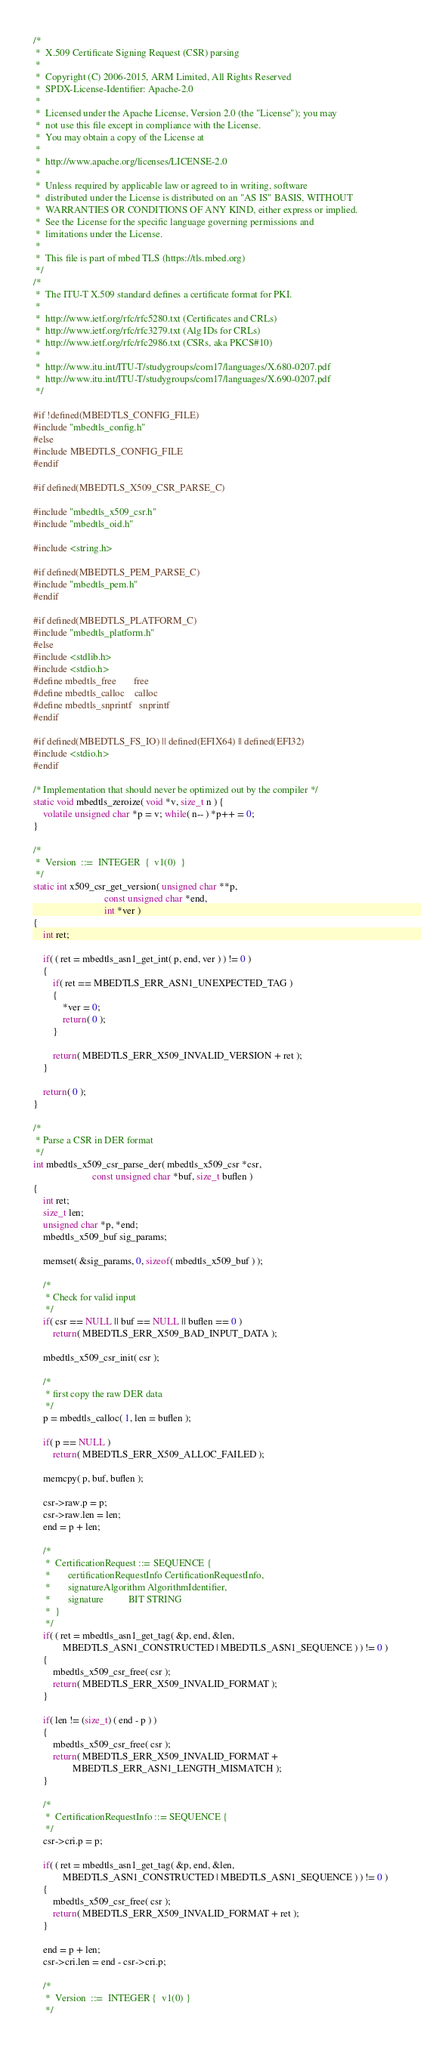<code> <loc_0><loc_0><loc_500><loc_500><_C_>/*
 *  X.509 Certificate Signing Request (CSR) parsing
 *
 *  Copyright (C) 2006-2015, ARM Limited, All Rights Reserved
 *  SPDX-License-Identifier: Apache-2.0
 *
 *  Licensed under the Apache License, Version 2.0 (the "License"); you may
 *  not use this file except in compliance with the License.
 *  You may obtain a copy of the License at
 *
 *  http://www.apache.org/licenses/LICENSE-2.0
 *
 *  Unless required by applicable law or agreed to in writing, software
 *  distributed under the License is distributed on an "AS IS" BASIS, WITHOUT
 *  WARRANTIES OR CONDITIONS OF ANY KIND, either express or implied.
 *  See the License for the specific language governing permissions and
 *  limitations under the License.
 *
 *  This file is part of mbed TLS (https://tls.mbed.org)
 */
/*
 *  The ITU-T X.509 standard defines a certificate format for PKI.
 *
 *  http://www.ietf.org/rfc/rfc5280.txt (Certificates and CRLs)
 *  http://www.ietf.org/rfc/rfc3279.txt (Alg IDs for CRLs)
 *  http://www.ietf.org/rfc/rfc2986.txt (CSRs, aka PKCS#10)
 *
 *  http://www.itu.int/ITU-T/studygroups/com17/languages/X.680-0207.pdf
 *  http://www.itu.int/ITU-T/studygroups/com17/languages/X.690-0207.pdf
 */

#if !defined(MBEDTLS_CONFIG_FILE)
#include "mbedtls_config.h"
#else
#include MBEDTLS_CONFIG_FILE
#endif

#if defined(MBEDTLS_X509_CSR_PARSE_C)

#include "mbedtls_x509_csr.h"
#include "mbedtls_oid.h"

#include <string.h>

#if defined(MBEDTLS_PEM_PARSE_C)
#include "mbedtls_pem.h"
#endif

#if defined(MBEDTLS_PLATFORM_C)
#include "mbedtls_platform.h"
#else
#include <stdlib.h>
#include <stdio.h>
#define mbedtls_free       free
#define mbedtls_calloc    calloc
#define mbedtls_snprintf   snprintf
#endif

#if defined(MBEDTLS_FS_IO) || defined(EFIX64) || defined(EFI32)
#include <stdio.h>
#endif

/* Implementation that should never be optimized out by the compiler */
static void mbedtls_zeroize( void *v, size_t n ) {
    volatile unsigned char *p = v; while( n-- ) *p++ = 0;
}

/*
 *  Version  ::=  INTEGER  {  v1(0)  }
 */
static int x509_csr_get_version( unsigned char **p,
                             const unsigned char *end,
                             int *ver )
{
    int ret;

    if( ( ret = mbedtls_asn1_get_int( p, end, ver ) ) != 0 )
    {
        if( ret == MBEDTLS_ERR_ASN1_UNEXPECTED_TAG )
        {
            *ver = 0;
            return( 0 );
        }

        return( MBEDTLS_ERR_X509_INVALID_VERSION + ret );
    }

    return( 0 );
}

/*
 * Parse a CSR in DER format
 */
int mbedtls_x509_csr_parse_der( mbedtls_x509_csr *csr,
                        const unsigned char *buf, size_t buflen )
{
    int ret;
    size_t len;
    unsigned char *p, *end;
    mbedtls_x509_buf sig_params;

    memset( &sig_params, 0, sizeof( mbedtls_x509_buf ) );

    /*
     * Check for valid input
     */
    if( csr == NULL || buf == NULL || buflen == 0 )
        return( MBEDTLS_ERR_X509_BAD_INPUT_DATA );

    mbedtls_x509_csr_init( csr );

    /*
     * first copy the raw DER data
     */
    p = mbedtls_calloc( 1, len = buflen );

    if( p == NULL )
        return( MBEDTLS_ERR_X509_ALLOC_FAILED );

    memcpy( p, buf, buflen );

    csr->raw.p = p;
    csr->raw.len = len;
    end = p + len;

    /*
     *  CertificationRequest ::= SEQUENCE {
     *       certificationRequestInfo CertificationRequestInfo,
     *       signatureAlgorithm AlgorithmIdentifier,
     *       signature          BIT STRING
     *  }
     */
    if( ( ret = mbedtls_asn1_get_tag( &p, end, &len,
            MBEDTLS_ASN1_CONSTRUCTED | MBEDTLS_ASN1_SEQUENCE ) ) != 0 )
    {
        mbedtls_x509_csr_free( csr );
        return( MBEDTLS_ERR_X509_INVALID_FORMAT );
    }

    if( len != (size_t) ( end - p ) )
    {
        mbedtls_x509_csr_free( csr );
        return( MBEDTLS_ERR_X509_INVALID_FORMAT +
                MBEDTLS_ERR_ASN1_LENGTH_MISMATCH );
    }

    /*
     *  CertificationRequestInfo ::= SEQUENCE {
     */
    csr->cri.p = p;

    if( ( ret = mbedtls_asn1_get_tag( &p, end, &len,
            MBEDTLS_ASN1_CONSTRUCTED | MBEDTLS_ASN1_SEQUENCE ) ) != 0 )
    {
        mbedtls_x509_csr_free( csr );
        return( MBEDTLS_ERR_X509_INVALID_FORMAT + ret );
    }

    end = p + len;
    csr->cri.len = end - csr->cri.p;

    /*
     *  Version  ::=  INTEGER {  v1(0) }
     */</code> 